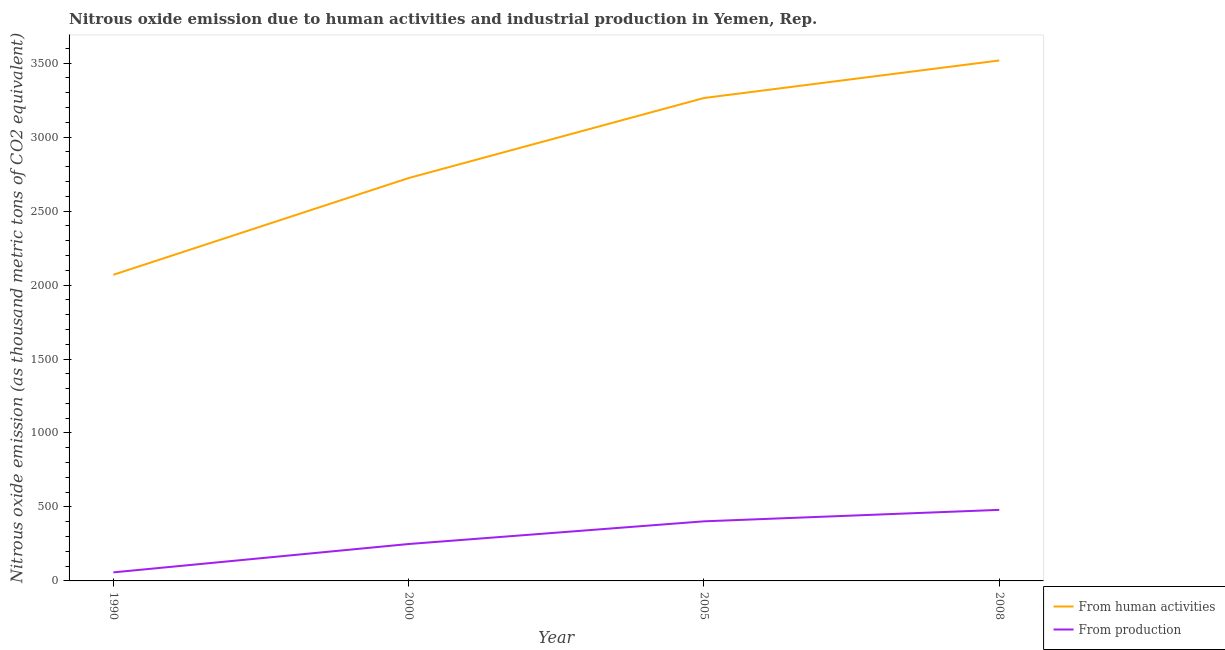Is the number of lines equal to the number of legend labels?
Your answer should be very brief. Yes. What is the amount of emissions generated from industries in 2008?
Your answer should be very brief. 480.4. Across all years, what is the maximum amount of emissions generated from industries?
Make the answer very short. 480.4. Across all years, what is the minimum amount of emissions generated from industries?
Offer a very short reply. 57.8. In which year was the amount of emissions generated from industries minimum?
Your response must be concise. 1990. What is the total amount of emissions from human activities in the graph?
Your response must be concise. 1.16e+04. What is the difference between the amount of emissions from human activities in 1990 and that in 2008?
Your answer should be compact. -1448.7. What is the difference between the amount of emissions generated from industries in 2008 and the amount of emissions from human activities in 2000?
Offer a very short reply. -2243.1. What is the average amount of emissions generated from industries per year?
Your answer should be very brief. 297.65. In the year 2000, what is the difference between the amount of emissions generated from industries and amount of emissions from human activities?
Ensure brevity in your answer.  -2474. What is the ratio of the amount of emissions from human activities in 1990 to that in 2000?
Your answer should be very brief. 0.76. Is the amount of emissions generated from industries in 2005 less than that in 2008?
Offer a very short reply. Yes. What is the difference between the highest and the second highest amount of emissions from human activities?
Make the answer very short. 253.8. What is the difference between the highest and the lowest amount of emissions from human activities?
Offer a terse response. 1448.7. In how many years, is the amount of emissions from human activities greater than the average amount of emissions from human activities taken over all years?
Your response must be concise. 2. Is the sum of the amount of emissions from human activities in 2005 and 2008 greater than the maximum amount of emissions generated from industries across all years?
Give a very brief answer. Yes. Does the amount of emissions from human activities monotonically increase over the years?
Offer a terse response. Yes. Is the amount of emissions generated from industries strictly greater than the amount of emissions from human activities over the years?
Your response must be concise. No. How many lines are there?
Your answer should be very brief. 2. What is the difference between two consecutive major ticks on the Y-axis?
Make the answer very short. 500. Does the graph contain any zero values?
Give a very brief answer. No. How many legend labels are there?
Your answer should be compact. 2. What is the title of the graph?
Your answer should be compact. Nitrous oxide emission due to human activities and industrial production in Yemen, Rep. Does "Female labor force" appear as one of the legend labels in the graph?
Give a very brief answer. No. What is the label or title of the X-axis?
Provide a succinct answer. Year. What is the label or title of the Y-axis?
Provide a short and direct response. Nitrous oxide emission (as thousand metric tons of CO2 equivalent). What is the Nitrous oxide emission (as thousand metric tons of CO2 equivalent) in From human activities in 1990?
Your answer should be very brief. 2069.6. What is the Nitrous oxide emission (as thousand metric tons of CO2 equivalent) of From production in 1990?
Your response must be concise. 57.8. What is the Nitrous oxide emission (as thousand metric tons of CO2 equivalent) in From human activities in 2000?
Provide a succinct answer. 2723.5. What is the Nitrous oxide emission (as thousand metric tons of CO2 equivalent) in From production in 2000?
Your response must be concise. 249.5. What is the Nitrous oxide emission (as thousand metric tons of CO2 equivalent) of From human activities in 2005?
Give a very brief answer. 3264.5. What is the Nitrous oxide emission (as thousand metric tons of CO2 equivalent) in From production in 2005?
Your response must be concise. 402.9. What is the Nitrous oxide emission (as thousand metric tons of CO2 equivalent) of From human activities in 2008?
Offer a very short reply. 3518.3. What is the Nitrous oxide emission (as thousand metric tons of CO2 equivalent) in From production in 2008?
Your answer should be very brief. 480.4. Across all years, what is the maximum Nitrous oxide emission (as thousand metric tons of CO2 equivalent) of From human activities?
Provide a short and direct response. 3518.3. Across all years, what is the maximum Nitrous oxide emission (as thousand metric tons of CO2 equivalent) in From production?
Your response must be concise. 480.4. Across all years, what is the minimum Nitrous oxide emission (as thousand metric tons of CO2 equivalent) in From human activities?
Provide a succinct answer. 2069.6. Across all years, what is the minimum Nitrous oxide emission (as thousand metric tons of CO2 equivalent) in From production?
Keep it short and to the point. 57.8. What is the total Nitrous oxide emission (as thousand metric tons of CO2 equivalent) in From human activities in the graph?
Provide a succinct answer. 1.16e+04. What is the total Nitrous oxide emission (as thousand metric tons of CO2 equivalent) in From production in the graph?
Your response must be concise. 1190.6. What is the difference between the Nitrous oxide emission (as thousand metric tons of CO2 equivalent) of From human activities in 1990 and that in 2000?
Give a very brief answer. -653.9. What is the difference between the Nitrous oxide emission (as thousand metric tons of CO2 equivalent) in From production in 1990 and that in 2000?
Ensure brevity in your answer.  -191.7. What is the difference between the Nitrous oxide emission (as thousand metric tons of CO2 equivalent) in From human activities in 1990 and that in 2005?
Your answer should be compact. -1194.9. What is the difference between the Nitrous oxide emission (as thousand metric tons of CO2 equivalent) of From production in 1990 and that in 2005?
Your response must be concise. -345.1. What is the difference between the Nitrous oxide emission (as thousand metric tons of CO2 equivalent) in From human activities in 1990 and that in 2008?
Give a very brief answer. -1448.7. What is the difference between the Nitrous oxide emission (as thousand metric tons of CO2 equivalent) in From production in 1990 and that in 2008?
Provide a succinct answer. -422.6. What is the difference between the Nitrous oxide emission (as thousand metric tons of CO2 equivalent) of From human activities in 2000 and that in 2005?
Provide a short and direct response. -541. What is the difference between the Nitrous oxide emission (as thousand metric tons of CO2 equivalent) of From production in 2000 and that in 2005?
Offer a very short reply. -153.4. What is the difference between the Nitrous oxide emission (as thousand metric tons of CO2 equivalent) of From human activities in 2000 and that in 2008?
Offer a very short reply. -794.8. What is the difference between the Nitrous oxide emission (as thousand metric tons of CO2 equivalent) in From production in 2000 and that in 2008?
Ensure brevity in your answer.  -230.9. What is the difference between the Nitrous oxide emission (as thousand metric tons of CO2 equivalent) in From human activities in 2005 and that in 2008?
Make the answer very short. -253.8. What is the difference between the Nitrous oxide emission (as thousand metric tons of CO2 equivalent) of From production in 2005 and that in 2008?
Give a very brief answer. -77.5. What is the difference between the Nitrous oxide emission (as thousand metric tons of CO2 equivalent) in From human activities in 1990 and the Nitrous oxide emission (as thousand metric tons of CO2 equivalent) in From production in 2000?
Ensure brevity in your answer.  1820.1. What is the difference between the Nitrous oxide emission (as thousand metric tons of CO2 equivalent) of From human activities in 1990 and the Nitrous oxide emission (as thousand metric tons of CO2 equivalent) of From production in 2005?
Ensure brevity in your answer.  1666.7. What is the difference between the Nitrous oxide emission (as thousand metric tons of CO2 equivalent) in From human activities in 1990 and the Nitrous oxide emission (as thousand metric tons of CO2 equivalent) in From production in 2008?
Provide a short and direct response. 1589.2. What is the difference between the Nitrous oxide emission (as thousand metric tons of CO2 equivalent) of From human activities in 2000 and the Nitrous oxide emission (as thousand metric tons of CO2 equivalent) of From production in 2005?
Ensure brevity in your answer.  2320.6. What is the difference between the Nitrous oxide emission (as thousand metric tons of CO2 equivalent) in From human activities in 2000 and the Nitrous oxide emission (as thousand metric tons of CO2 equivalent) in From production in 2008?
Keep it short and to the point. 2243.1. What is the difference between the Nitrous oxide emission (as thousand metric tons of CO2 equivalent) of From human activities in 2005 and the Nitrous oxide emission (as thousand metric tons of CO2 equivalent) of From production in 2008?
Offer a terse response. 2784.1. What is the average Nitrous oxide emission (as thousand metric tons of CO2 equivalent) in From human activities per year?
Provide a succinct answer. 2893.97. What is the average Nitrous oxide emission (as thousand metric tons of CO2 equivalent) of From production per year?
Ensure brevity in your answer.  297.65. In the year 1990, what is the difference between the Nitrous oxide emission (as thousand metric tons of CO2 equivalent) of From human activities and Nitrous oxide emission (as thousand metric tons of CO2 equivalent) of From production?
Keep it short and to the point. 2011.8. In the year 2000, what is the difference between the Nitrous oxide emission (as thousand metric tons of CO2 equivalent) of From human activities and Nitrous oxide emission (as thousand metric tons of CO2 equivalent) of From production?
Offer a very short reply. 2474. In the year 2005, what is the difference between the Nitrous oxide emission (as thousand metric tons of CO2 equivalent) in From human activities and Nitrous oxide emission (as thousand metric tons of CO2 equivalent) in From production?
Offer a terse response. 2861.6. In the year 2008, what is the difference between the Nitrous oxide emission (as thousand metric tons of CO2 equivalent) in From human activities and Nitrous oxide emission (as thousand metric tons of CO2 equivalent) in From production?
Provide a succinct answer. 3037.9. What is the ratio of the Nitrous oxide emission (as thousand metric tons of CO2 equivalent) of From human activities in 1990 to that in 2000?
Make the answer very short. 0.76. What is the ratio of the Nitrous oxide emission (as thousand metric tons of CO2 equivalent) of From production in 1990 to that in 2000?
Make the answer very short. 0.23. What is the ratio of the Nitrous oxide emission (as thousand metric tons of CO2 equivalent) of From human activities in 1990 to that in 2005?
Your answer should be very brief. 0.63. What is the ratio of the Nitrous oxide emission (as thousand metric tons of CO2 equivalent) in From production in 1990 to that in 2005?
Your answer should be very brief. 0.14. What is the ratio of the Nitrous oxide emission (as thousand metric tons of CO2 equivalent) of From human activities in 1990 to that in 2008?
Your answer should be compact. 0.59. What is the ratio of the Nitrous oxide emission (as thousand metric tons of CO2 equivalent) of From production in 1990 to that in 2008?
Your response must be concise. 0.12. What is the ratio of the Nitrous oxide emission (as thousand metric tons of CO2 equivalent) in From human activities in 2000 to that in 2005?
Your response must be concise. 0.83. What is the ratio of the Nitrous oxide emission (as thousand metric tons of CO2 equivalent) of From production in 2000 to that in 2005?
Your answer should be compact. 0.62. What is the ratio of the Nitrous oxide emission (as thousand metric tons of CO2 equivalent) in From human activities in 2000 to that in 2008?
Offer a terse response. 0.77. What is the ratio of the Nitrous oxide emission (as thousand metric tons of CO2 equivalent) of From production in 2000 to that in 2008?
Your answer should be very brief. 0.52. What is the ratio of the Nitrous oxide emission (as thousand metric tons of CO2 equivalent) of From human activities in 2005 to that in 2008?
Offer a very short reply. 0.93. What is the ratio of the Nitrous oxide emission (as thousand metric tons of CO2 equivalent) of From production in 2005 to that in 2008?
Offer a very short reply. 0.84. What is the difference between the highest and the second highest Nitrous oxide emission (as thousand metric tons of CO2 equivalent) in From human activities?
Your answer should be very brief. 253.8. What is the difference between the highest and the second highest Nitrous oxide emission (as thousand metric tons of CO2 equivalent) in From production?
Make the answer very short. 77.5. What is the difference between the highest and the lowest Nitrous oxide emission (as thousand metric tons of CO2 equivalent) of From human activities?
Offer a very short reply. 1448.7. What is the difference between the highest and the lowest Nitrous oxide emission (as thousand metric tons of CO2 equivalent) of From production?
Ensure brevity in your answer.  422.6. 